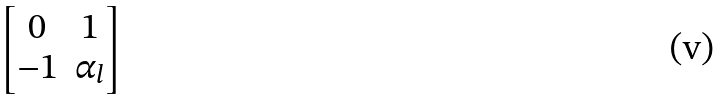<formula> <loc_0><loc_0><loc_500><loc_500>\begin{bmatrix} 0 & 1 \\ - 1 & \alpha _ { l } \end{bmatrix}</formula> 